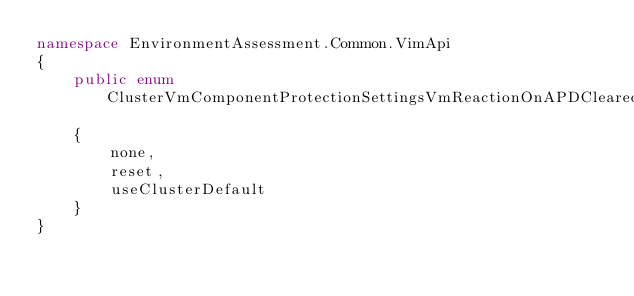Convert code to text. <code><loc_0><loc_0><loc_500><loc_500><_C#_>namespace EnvironmentAssessment.Common.VimApi
{
	public enum ClusterVmComponentProtectionSettingsVmReactionOnAPDCleared
	{
		none,
		reset,
		useClusterDefault
	}
}
</code> 